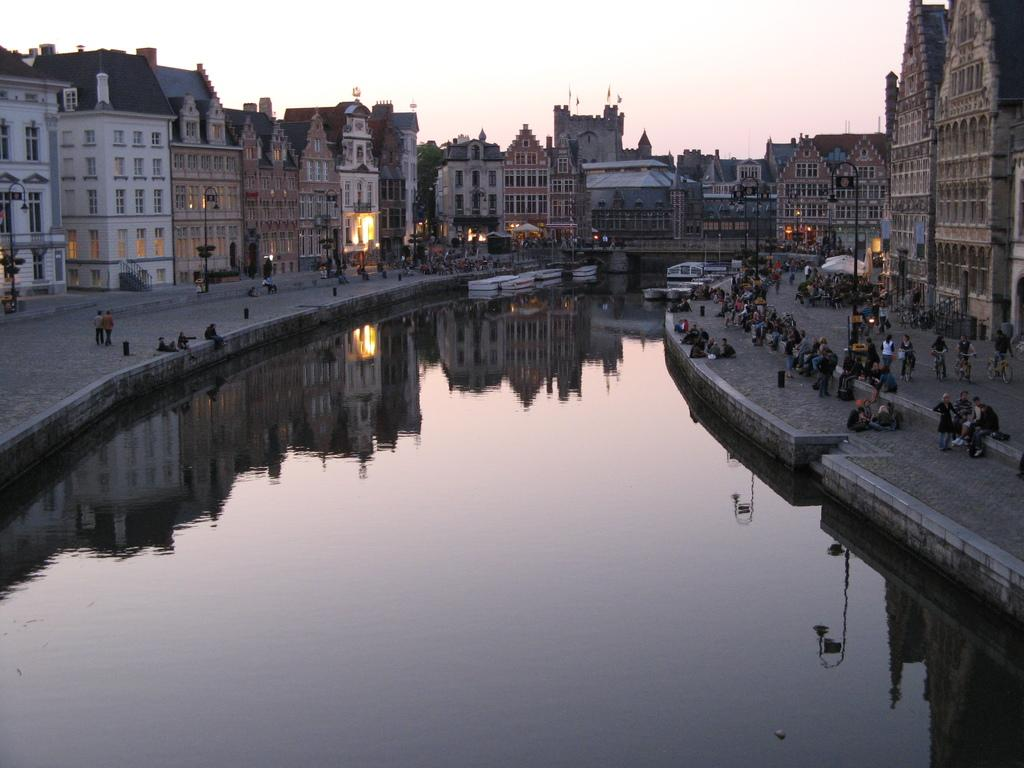What is the main feature in the center of the image? There is water in the center of the image. What can be seen on both sides of the water? There are buildings on both sides of the image. Are there any living beings in the image? Yes, there are people in the image. What connects the two sides of the water? There is a bridge in the image. What type of pencil is being used by the people in the image? There is no pencil visible in the image; the people are not depicted using any writing instruments. 